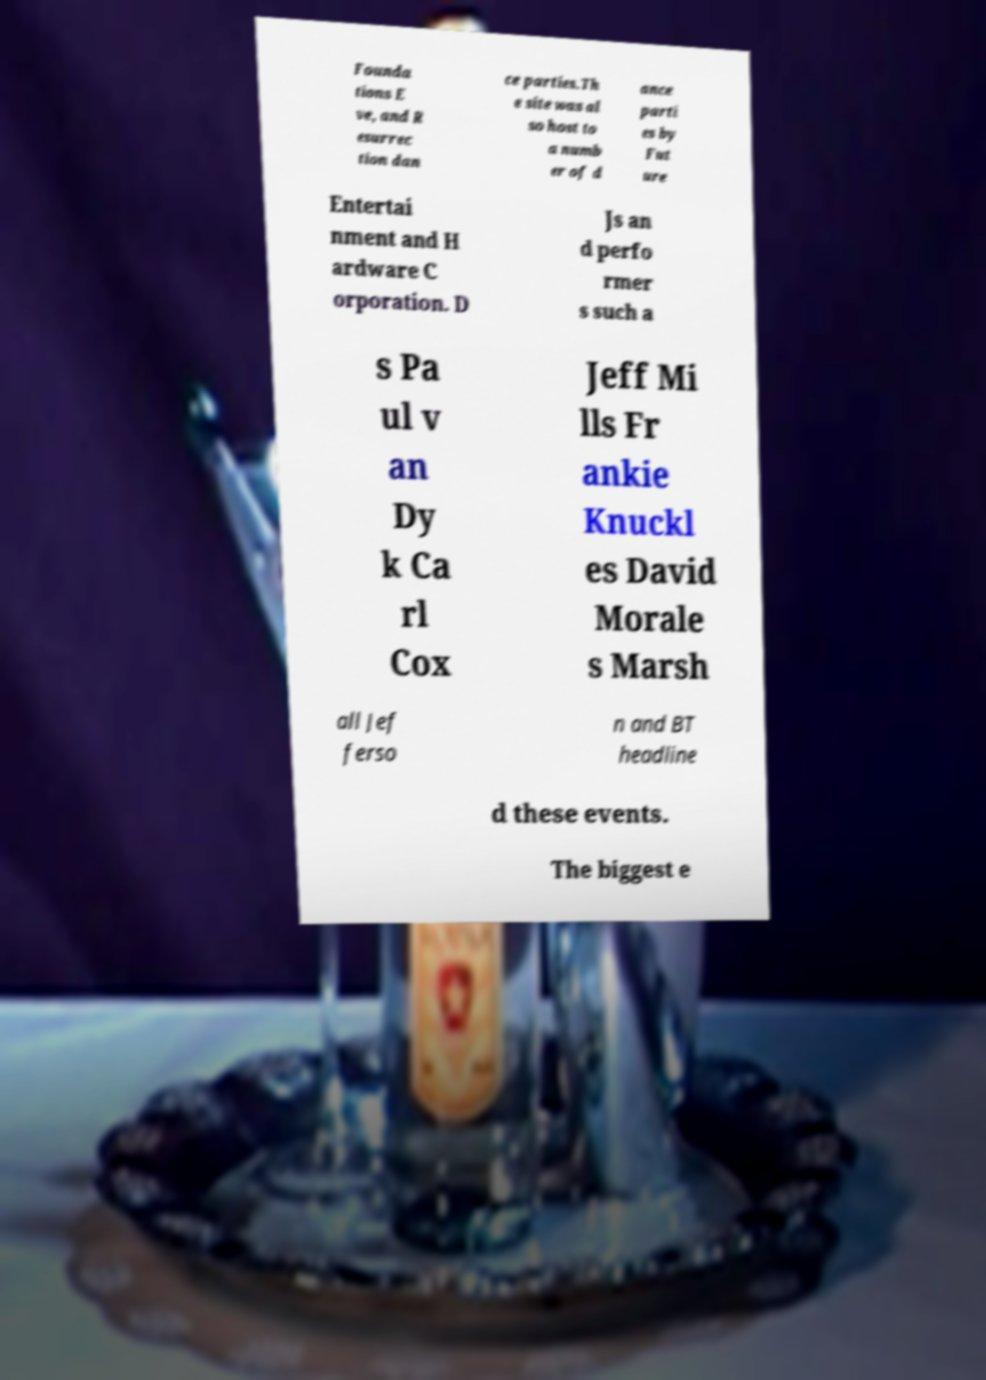Please identify and transcribe the text found in this image. Founda tions E ve, and R esurrec tion dan ce parties.Th e site was al so host to a numb er of d ance parti es by Fut ure Entertai nment and H ardware C orporation. D Js an d perfo rmer s such a s Pa ul v an Dy k Ca rl Cox Jeff Mi lls Fr ankie Knuckl es David Morale s Marsh all Jef ferso n and BT headline d these events. The biggest e 